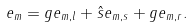<formula> <loc_0><loc_0><loc_500><loc_500>e _ { m } = g e _ { m , l } + \hat { s } e _ { m , s } + g e _ { m , r } .</formula> 